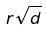<formula> <loc_0><loc_0><loc_500><loc_500>r \sqrt { d }</formula> 